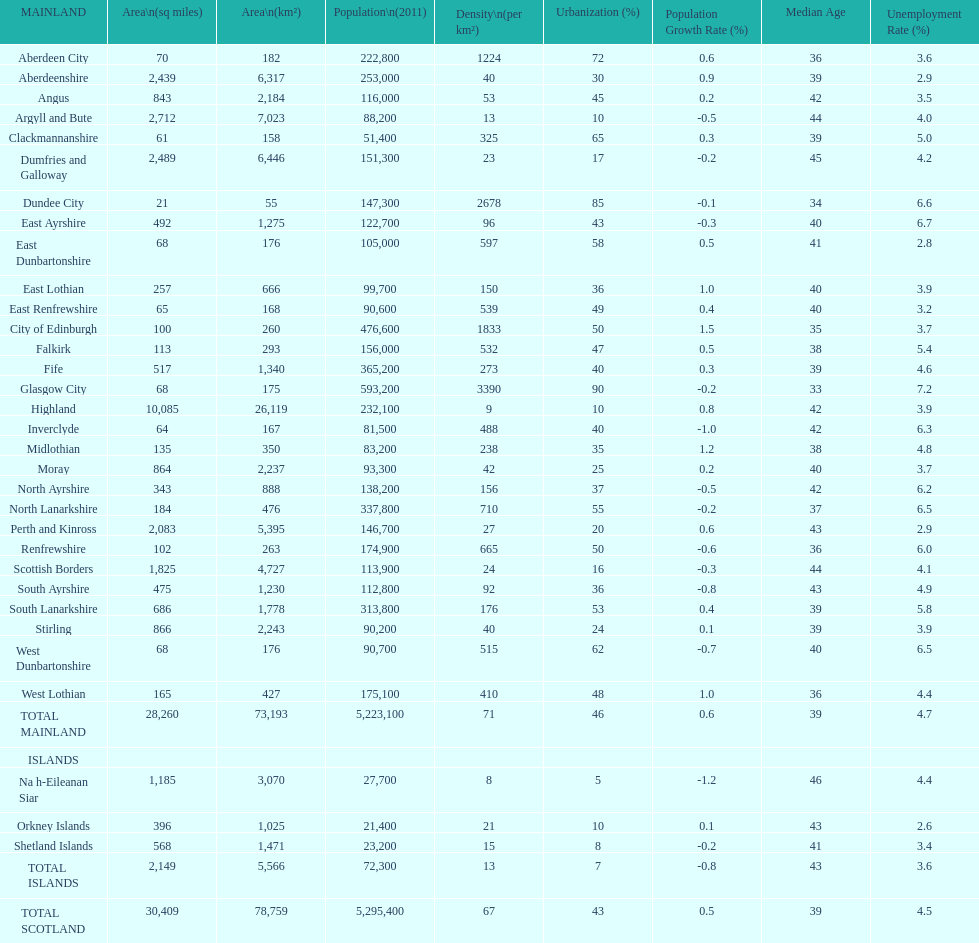Which is the only subdivision to have a greater area than argyll and bute? Highland. 